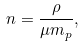Convert formula to latex. <formula><loc_0><loc_0><loc_500><loc_500>n = \frac { \rho } { \mu m _ { p } } ,</formula> 